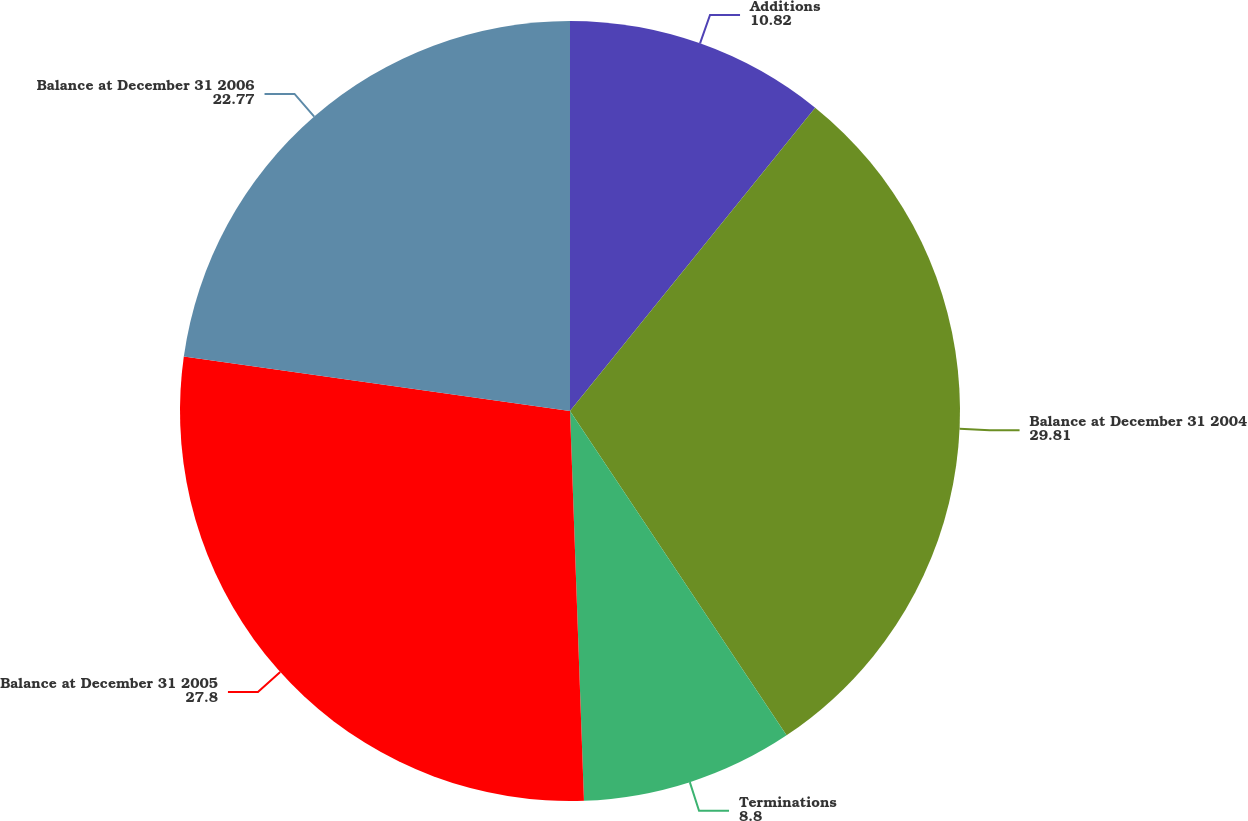<chart> <loc_0><loc_0><loc_500><loc_500><pie_chart><fcel>Additions<fcel>Balance at December 31 2004<fcel>Terminations<fcel>Balance at December 31 2005<fcel>Balance at December 31 2006<nl><fcel>10.82%<fcel>29.81%<fcel>8.8%<fcel>27.8%<fcel>22.77%<nl></chart> 